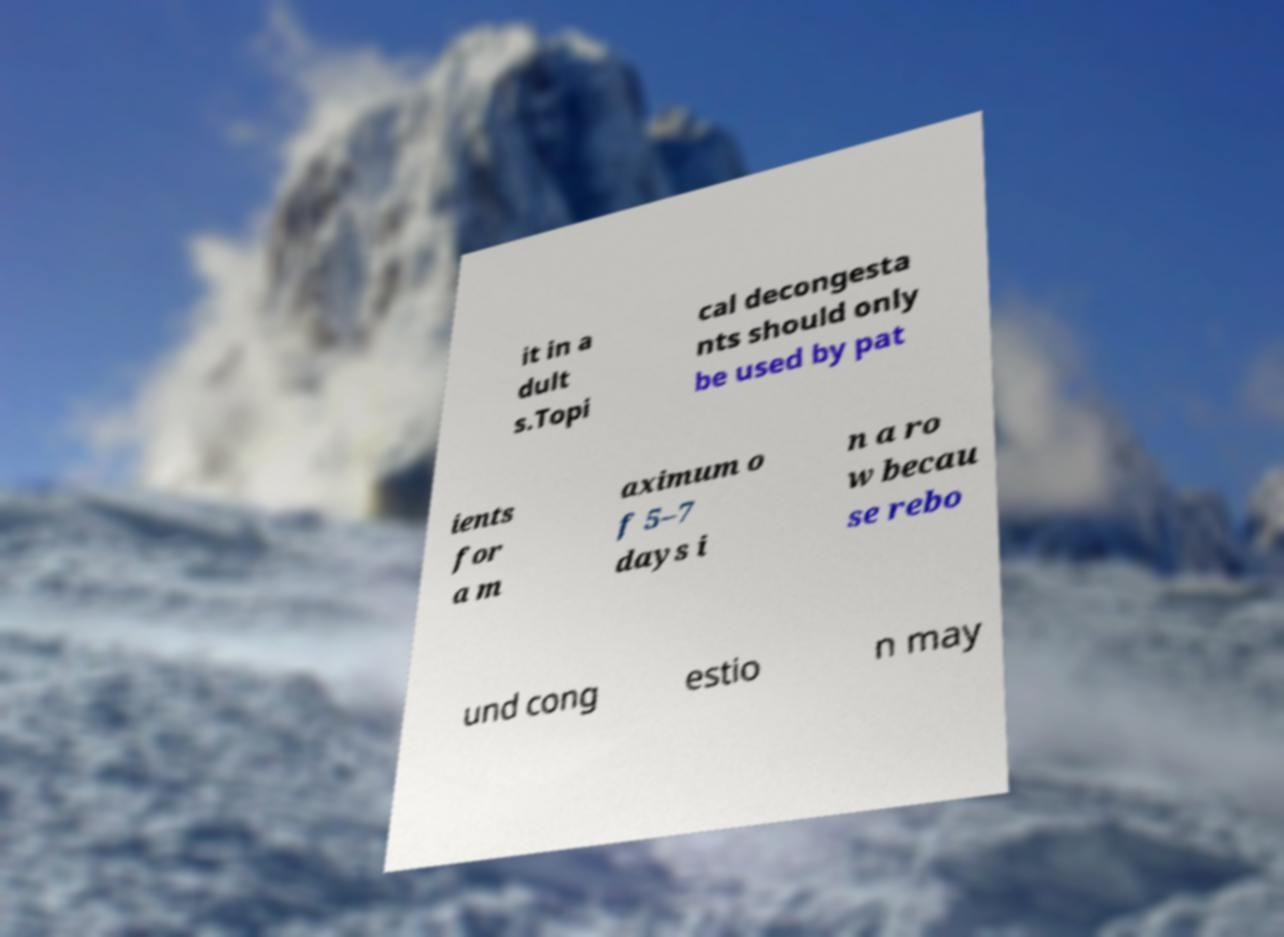Could you assist in decoding the text presented in this image and type it out clearly? it in a dult s.Topi cal decongesta nts should only be used by pat ients for a m aximum o f 5–7 days i n a ro w becau se rebo und cong estio n may 